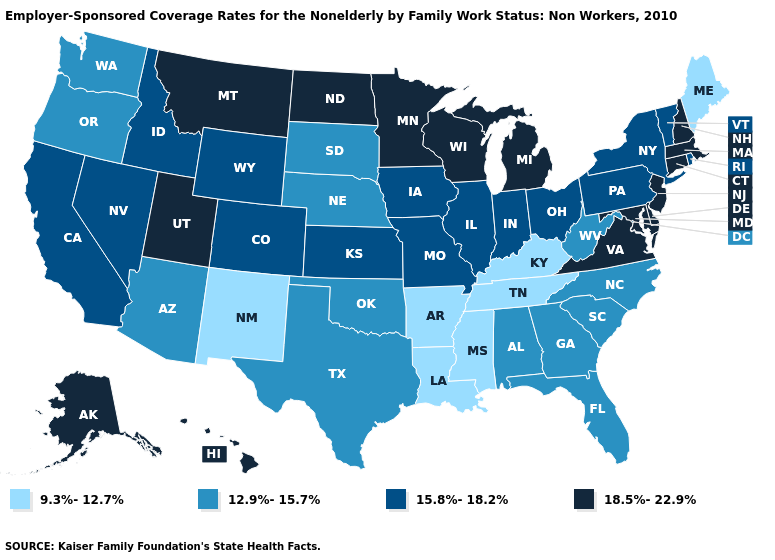What is the highest value in the MidWest ?
Quick response, please. 18.5%-22.9%. Is the legend a continuous bar?
Keep it brief. No. Name the states that have a value in the range 9.3%-12.7%?
Write a very short answer. Arkansas, Kentucky, Louisiana, Maine, Mississippi, New Mexico, Tennessee. Among the states that border Texas , does Louisiana have the highest value?
Be succinct. No. What is the highest value in the USA?
Short answer required. 18.5%-22.9%. Among the states that border Vermont , does New York have the lowest value?
Be succinct. Yes. Does Georgia have the highest value in the South?
Quick response, please. No. Is the legend a continuous bar?
Quick response, please. No. Name the states that have a value in the range 9.3%-12.7%?
Keep it brief. Arkansas, Kentucky, Louisiana, Maine, Mississippi, New Mexico, Tennessee. What is the lowest value in the Northeast?
Be succinct. 9.3%-12.7%. Does New Mexico have the lowest value in the USA?
Be succinct. Yes. What is the highest value in the West ?
Short answer required. 18.5%-22.9%. Which states have the highest value in the USA?
Answer briefly. Alaska, Connecticut, Delaware, Hawaii, Maryland, Massachusetts, Michigan, Minnesota, Montana, New Hampshire, New Jersey, North Dakota, Utah, Virginia, Wisconsin. What is the lowest value in the South?
Answer briefly. 9.3%-12.7%. Among the states that border New Hampshire , does Vermont have the lowest value?
Be succinct. No. 